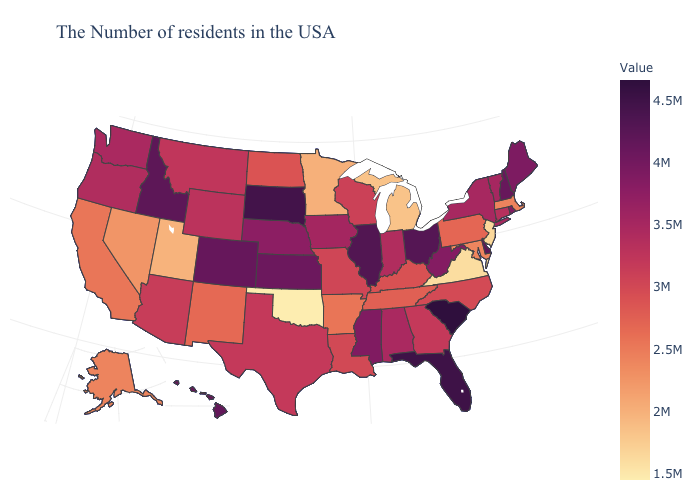Does Oklahoma have the lowest value in the South?
Quick response, please. Yes. Among the states that border Utah , which have the lowest value?
Write a very short answer. Nevada. Does Utah have a lower value than New Jersey?
Keep it brief. No. Which states have the lowest value in the USA?
Keep it brief. Oklahoma. Which states have the lowest value in the USA?
Short answer required. Oklahoma. Among the states that border Connecticut , which have the highest value?
Answer briefly. Rhode Island. 